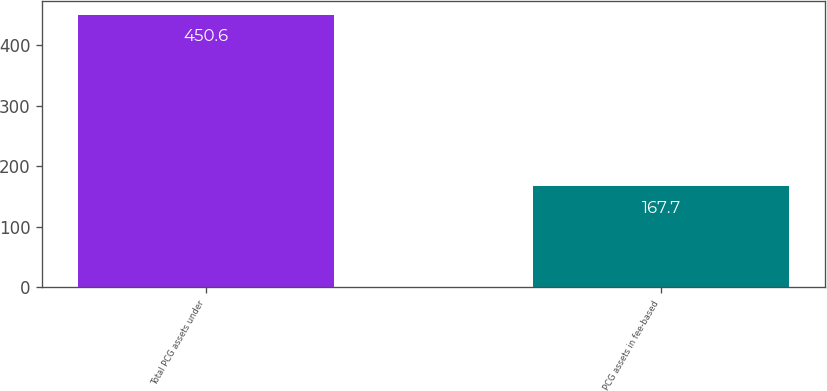Convert chart to OTSL. <chart><loc_0><loc_0><loc_500><loc_500><bar_chart><fcel>Total PCG assets under<fcel>PCG assets in fee-based<nl><fcel>450.6<fcel>167.7<nl></chart> 